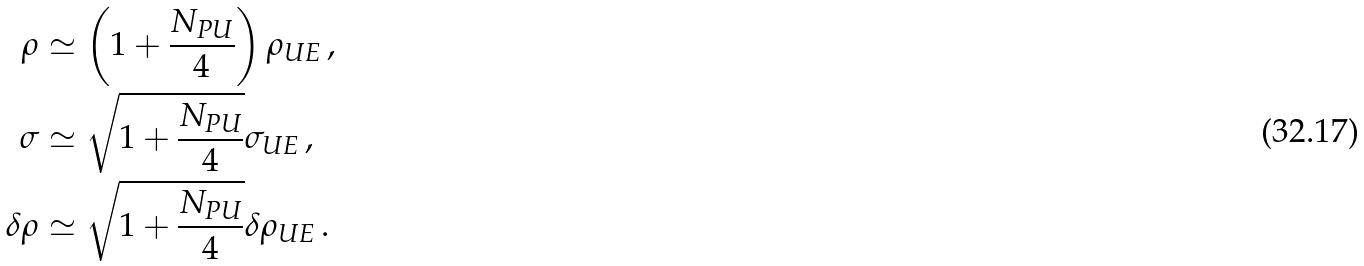<formula> <loc_0><loc_0><loc_500><loc_500>\rho & \simeq \left ( 1 + \frac { N _ { P U } } { 4 } \right ) \rho _ { U E } \, , \\ \sigma & \simeq \sqrt { 1 + \frac { N _ { P U } } { 4 } } \sigma _ { U E } \, , \\ \delta \rho & \simeq \sqrt { 1 + \frac { N _ { P U } } { 4 } } \delta \rho _ { U E } \, .</formula> 